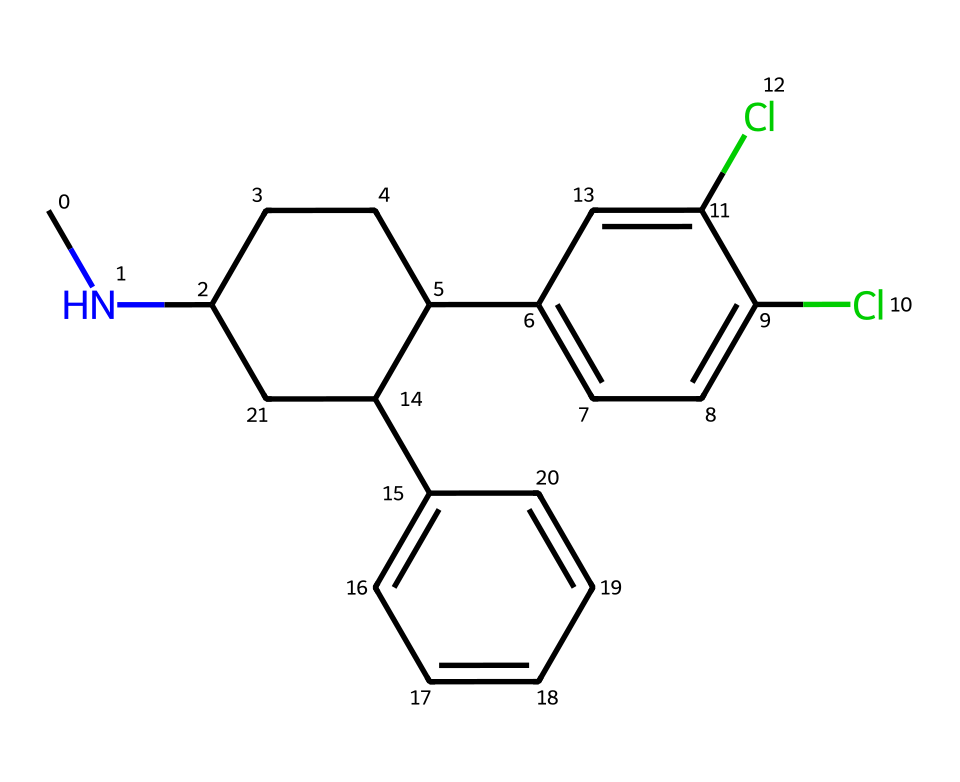how many carbon atoms are in sertraline? Counting the carbon atoms in the SMILES representation reveals a total of 19 carbon atoms. Each 'C' in the SMILES corresponds to a carbon atom.
Answer: 19 how many chlorine atoms are present in the structure? The SMILES representation contains two occurrences of 'Cl', indicating there are 2 chlorine atoms in the structure.
Answer: 2 what is the primary functional group present in sertraline? The presence of a nitrogen atom (CNC) suggests the compound contains a secondary amine functional group, which is typical in many antidepressants.
Answer: secondary amine is sertraline a linear or cyclic compound? The structure comprises both cyclic (C1CCC and C2=CC) and acyclic components, indicating that sertraline contains rings as part of its structure.
Answer: cyclic what type of chemical bond connects the carbon atoms in sertraline? The carbon atoms are primarily connected by single and double bonds, which are typical covalent bonds in organic compounds.
Answer: covalent which part of the structure could be responsible for the drug's interaction with serotonin? The nitrogen atom within the amine group (CNC) is likely significant in binding to the serotonin receptors, allowing for its antidepressant effects.
Answer: nitrogen atom how does the arrangement of chlorine atoms influence the properties of sertraline? The chlorination (presence of Cl groups) likely alters the electronic properties and increases the lipophilicity, affecting the drug's pharmacokinetics and receptor binding.
Answer: increases lipophilicity 